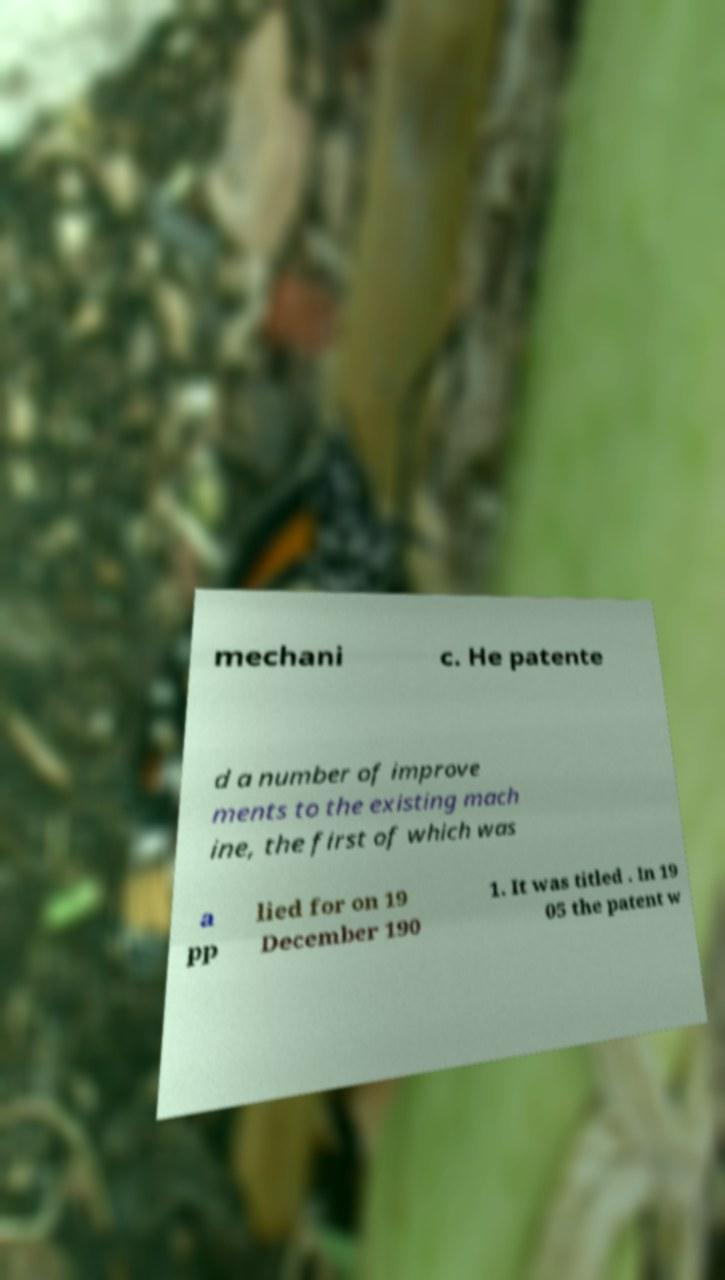What messages or text are displayed in this image? I need them in a readable, typed format. mechani c. He patente d a number of improve ments to the existing mach ine, the first of which was a pp lied for on 19 December 190 1. It was titled . In 19 05 the patent w 